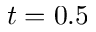Convert formula to latex. <formula><loc_0><loc_0><loc_500><loc_500>t = 0 . 5</formula> 